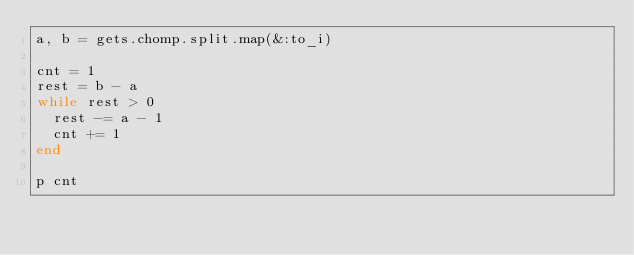<code> <loc_0><loc_0><loc_500><loc_500><_Ruby_>a, b = gets.chomp.split.map(&:to_i)

cnt = 1
rest = b - a
while rest > 0
  rest -= a - 1
  cnt += 1
end

p cnt
</code> 